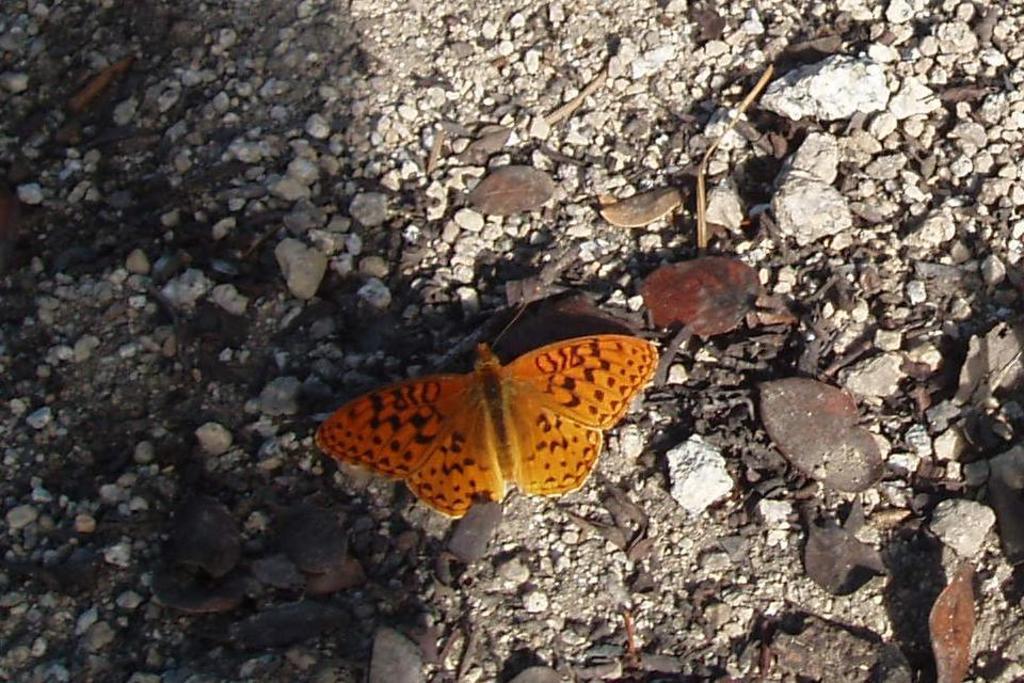Can you describe this image briefly? In this image we can see the stones, dried leaves and also a butterfly. 